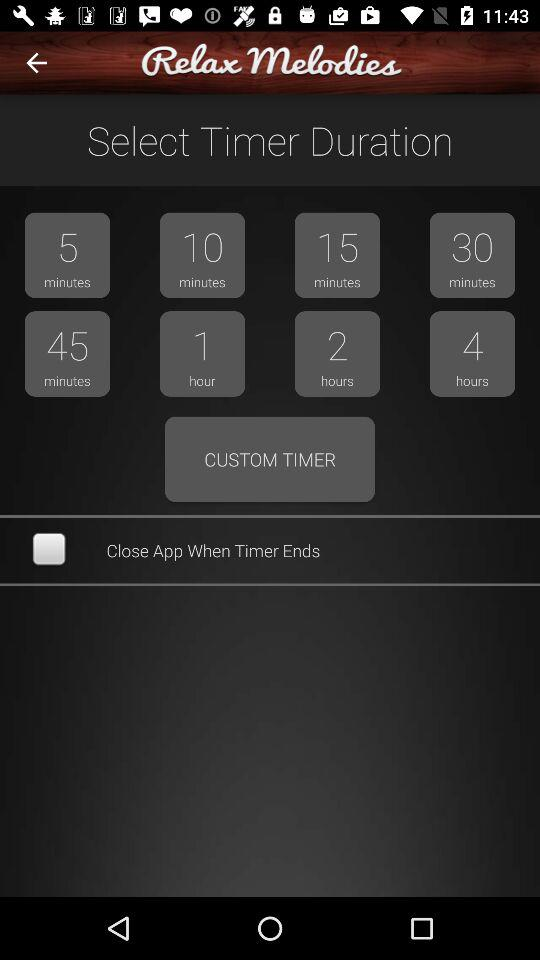What are the timer options that I can select? The timer options that you can select are "5 minutes", "10 minutes", "15 minutes", "30 minutes", "45 minutes", "1 hour", "2 hours" and "4 hours". 